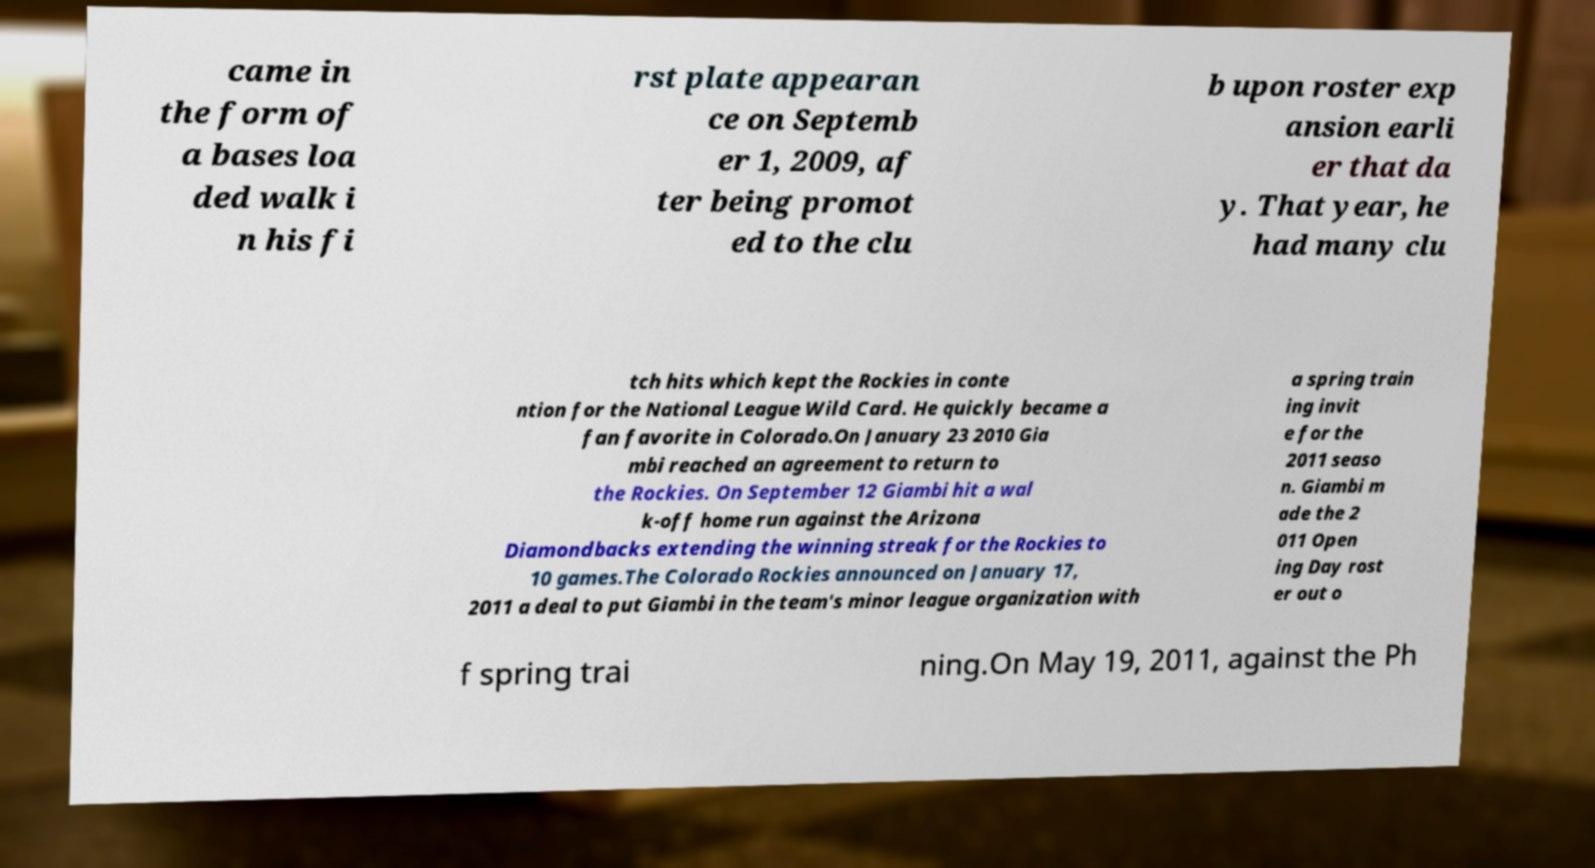Can you read and provide the text displayed in the image?This photo seems to have some interesting text. Can you extract and type it out for me? came in the form of a bases loa ded walk i n his fi rst plate appearan ce on Septemb er 1, 2009, af ter being promot ed to the clu b upon roster exp ansion earli er that da y. That year, he had many clu tch hits which kept the Rockies in conte ntion for the National League Wild Card. He quickly became a fan favorite in Colorado.On January 23 2010 Gia mbi reached an agreement to return to the Rockies. On September 12 Giambi hit a wal k-off home run against the Arizona Diamondbacks extending the winning streak for the Rockies to 10 games.The Colorado Rockies announced on January 17, 2011 a deal to put Giambi in the team's minor league organization with a spring train ing invit e for the 2011 seaso n. Giambi m ade the 2 011 Open ing Day rost er out o f spring trai ning.On May 19, 2011, against the Ph 